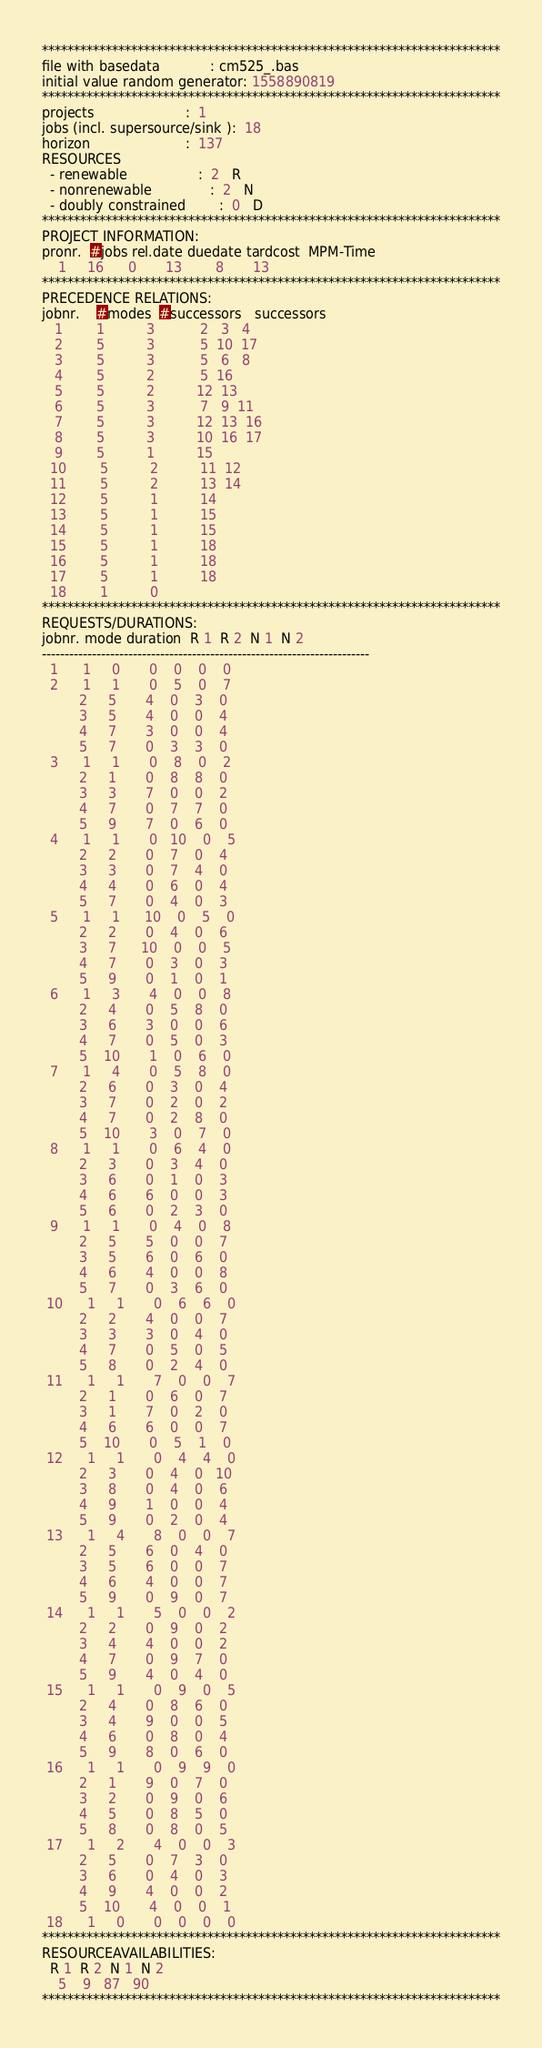<code> <loc_0><loc_0><loc_500><loc_500><_ObjectiveC_>************************************************************************
file with basedata            : cm525_.bas
initial value random generator: 1558890819
************************************************************************
projects                      :  1
jobs (incl. supersource/sink ):  18
horizon                       :  137
RESOURCES
  - renewable                 :  2   R
  - nonrenewable              :  2   N
  - doubly constrained        :  0   D
************************************************************************
PROJECT INFORMATION:
pronr.  #jobs rel.date duedate tardcost  MPM-Time
    1     16      0       13        8       13
************************************************************************
PRECEDENCE RELATIONS:
jobnr.    #modes  #successors   successors
   1        1          3           2   3   4
   2        5          3           5  10  17
   3        5          3           5   6   8
   4        5          2           5  16
   5        5          2          12  13
   6        5          3           7   9  11
   7        5          3          12  13  16
   8        5          3          10  16  17
   9        5          1          15
  10        5          2          11  12
  11        5          2          13  14
  12        5          1          14
  13        5          1          15
  14        5          1          15
  15        5          1          18
  16        5          1          18
  17        5          1          18
  18        1          0        
************************************************************************
REQUESTS/DURATIONS:
jobnr. mode duration  R 1  R 2  N 1  N 2
------------------------------------------------------------------------
  1      1     0       0    0    0    0
  2      1     1       0    5    0    7
         2     5       4    0    3    0
         3     5       4    0    0    4
         4     7       3    0    0    4
         5     7       0    3    3    0
  3      1     1       0    8    0    2
         2     1       0    8    8    0
         3     3       7    0    0    2
         4     7       0    7    7    0
         5     9       7    0    6    0
  4      1     1       0   10    0    5
         2     2       0    7    0    4
         3     3       0    7    4    0
         4     4       0    6    0    4
         5     7       0    4    0    3
  5      1     1      10    0    5    0
         2     2       0    4    0    6
         3     7      10    0    0    5
         4     7       0    3    0    3
         5     9       0    1    0    1
  6      1     3       4    0    0    8
         2     4       0    5    8    0
         3     6       3    0    0    6
         4     7       0    5    0    3
         5    10       1    0    6    0
  7      1     4       0    5    8    0
         2     6       0    3    0    4
         3     7       0    2    0    2
         4     7       0    2    8    0
         5    10       3    0    7    0
  8      1     1       0    6    4    0
         2     3       0    3    4    0
         3     6       0    1    0    3
         4     6       6    0    0    3
         5     6       0    2    3    0
  9      1     1       0    4    0    8
         2     5       5    0    0    7
         3     5       6    0    6    0
         4     6       4    0    0    8
         5     7       0    3    6    0
 10      1     1       0    6    6    0
         2     2       4    0    0    7
         3     3       3    0    4    0
         4     7       0    5    0    5
         5     8       0    2    4    0
 11      1     1       7    0    0    7
         2     1       0    6    0    7
         3     1       7    0    2    0
         4     6       6    0    0    7
         5    10       0    5    1    0
 12      1     1       0    4    4    0
         2     3       0    4    0   10
         3     8       0    4    0    6
         4     9       1    0    0    4
         5     9       0    2    0    4
 13      1     4       8    0    0    7
         2     5       6    0    4    0
         3     5       6    0    0    7
         4     6       4    0    0    7
         5     9       0    9    0    7
 14      1     1       5    0    0    2
         2     2       0    9    0    2
         3     4       4    0    0    2
         4     7       0    9    7    0
         5     9       4    0    4    0
 15      1     1       0    9    0    5
         2     4       0    8    6    0
         3     4       9    0    0    5
         4     6       0    8    0    4
         5     9       8    0    6    0
 16      1     1       0    9    9    0
         2     1       9    0    7    0
         3     2       0    9    0    6
         4     5       0    8    5    0
         5     8       0    8    0    5
 17      1     2       4    0    0    3
         2     5       0    7    3    0
         3     6       0    4    0    3
         4     9       4    0    0    2
         5    10       4    0    0    1
 18      1     0       0    0    0    0
************************************************************************
RESOURCEAVAILABILITIES:
  R 1  R 2  N 1  N 2
    5    9   87   90
************************************************************************
</code> 